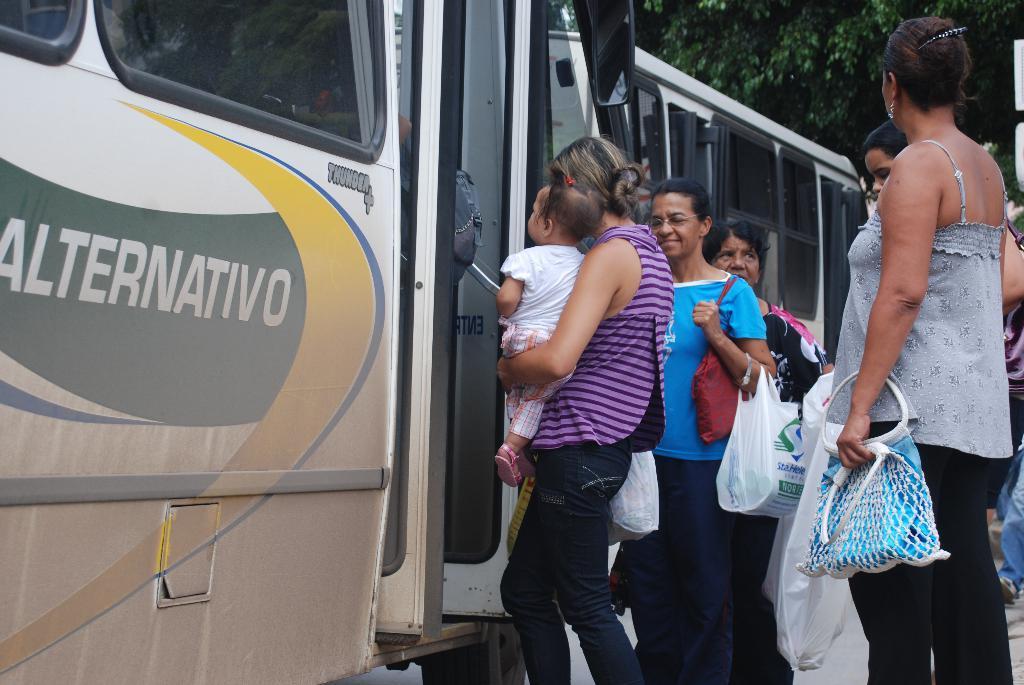How would you summarize this image in a sentence or two? In this image we can see people standing. To the left side of the image there is a bus. In the background of the image there is a bus, tree. 